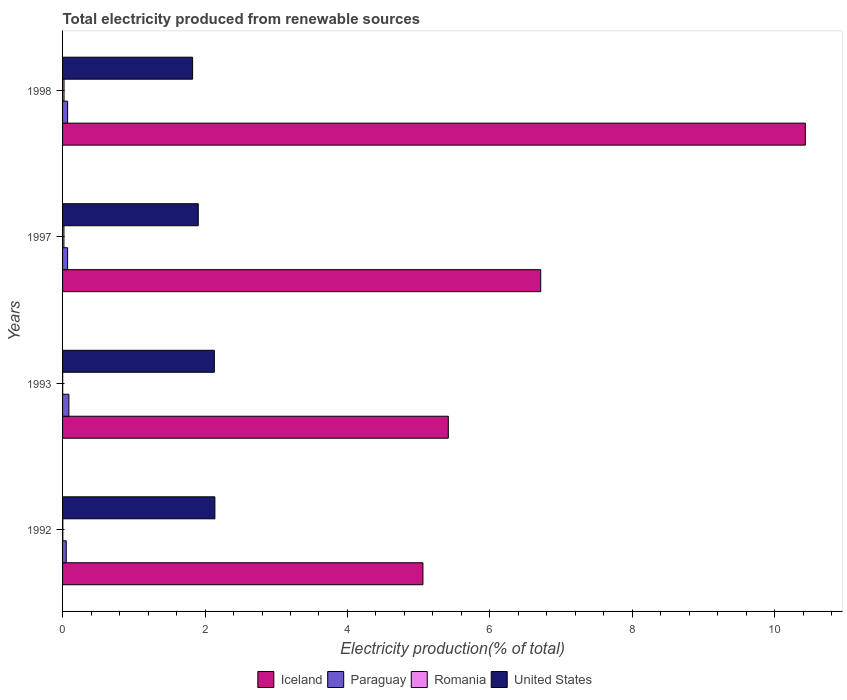How many groups of bars are there?
Offer a terse response. 4. Are the number of bars per tick equal to the number of legend labels?
Provide a succinct answer. Yes. Are the number of bars on each tick of the Y-axis equal?
Provide a short and direct response. Yes. How many bars are there on the 3rd tick from the top?
Your response must be concise. 4. How many bars are there on the 2nd tick from the bottom?
Your response must be concise. 4. What is the total electricity produced in Paraguay in 1993?
Provide a short and direct response. 0.09. Across all years, what is the maximum total electricity produced in United States?
Offer a terse response. 2.14. Across all years, what is the minimum total electricity produced in Paraguay?
Your answer should be very brief. 0.05. In which year was the total electricity produced in Paraguay minimum?
Ensure brevity in your answer.  1992. What is the total total electricity produced in Paraguay in the graph?
Offer a very short reply. 0.28. What is the difference between the total electricity produced in Paraguay in 1993 and that in 1998?
Provide a succinct answer. 0.02. What is the difference between the total electricity produced in Romania in 1993 and the total electricity produced in Iceland in 1998?
Keep it short and to the point. -10.43. What is the average total electricity produced in Paraguay per year?
Provide a succinct answer. 0.07. In the year 1992, what is the difference between the total electricity produced in Romania and total electricity produced in Paraguay?
Keep it short and to the point. -0.05. In how many years, is the total electricity produced in Paraguay greater than 3.2 %?
Ensure brevity in your answer.  0. What is the ratio of the total electricity produced in Paraguay in 1993 to that in 1997?
Offer a very short reply. 1.26. Is the total electricity produced in Romania in 1993 less than that in 1997?
Your answer should be compact. Yes. What is the difference between the highest and the second highest total electricity produced in Romania?
Give a very brief answer. 0. What is the difference between the highest and the lowest total electricity produced in Iceland?
Keep it short and to the point. 5.37. In how many years, is the total electricity produced in Romania greater than the average total electricity produced in Romania taken over all years?
Your answer should be very brief. 2. Is the sum of the total electricity produced in United States in 1992 and 1997 greater than the maximum total electricity produced in Paraguay across all years?
Provide a succinct answer. Yes. Is it the case that in every year, the sum of the total electricity produced in Paraguay and total electricity produced in United States is greater than the sum of total electricity produced in Iceland and total electricity produced in Romania?
Your response must be concise. Yes. What does the 1st bar from the top in 1998 represents?
Your answer should be compact. United States. What does the 3rd bar from the bottom in 1997 represents?
Give a very brief answer. Romania. Is it the case that in every year, the sum of the total electricity produced in Iceland and total electricity produced in United States is greater than the total electricity produced in Paraguay?
Your answer should be compact. Yes. How many years are there in the graph?
Make the answer very short. 4. What is the difference between two consecutive major ticks on the X-axis?
Ensure brevity in your answer.  2. Does the graph contain any zero values?
Your response must be concise. No. How many legend labels are there?
Provide a succinct answer. 4. What is the title of the graph?
Offer a terse response. Total electricity produced from renewable sources. What is the label or title of the Y-axis?
Make the answer very short. Years. What is the Electricity production(% of total) of Iceland in 1992?
Provide a succinct answer. 5.06. What is the Electricity production(% of total) of Paraguay in 1992?
Provide a short and direct response. 0.05. What is the Electricity production(% of total) of Romania in 1992?
Ensure brevity in your answer.  0. What is the Electricity production(% of total) of United States in 1992?
Your response must be concise. 2.14. What is the Electricity production(% of total) of Iceland in 1993?
Your answer should be compact. 5.42. What is the Electricity production(% of total) of Paraguay in 1993?
Make the answer very short. 0.09. What is the Electricity production(% of total) in Romania in 1993?
Your answer should be compact. 0. What is the Electricity production(% of total) of United States in 1993?
Your answer should be compact. 2.13. What is the Electricity production(% of total) of Iceland in 1997?
Your answer should be compact. 6.71. What is the Electricity production(% of total) in Paraguay in 1997?
Offer a terse response. 0.07. What is the Electricity production(% of total) of Romania in 1997?
Provide a succinct answer. 0.02. What is the Electricity production(% of total) of United States in 1997?
Provide a succinct answer. 1.9. What is the Electricity production(% of total) in Iceland in 1998?
Offer a terse response. 10.43. What is the Electricity production(% of total) in Paraguay in 1998?
Your answer should be compact. 0.07. What is the Electricity production(% of total) of Romania in 1998?
Make the answer very short. 0.02. What is the Electricity production(% of total) in United States in 1998?
Your response must be concise. 1.83. Across all years, what is the maximum Electricity production(% of total) in Iceland?
Make the answer very short. 10.43. Across all years, what is the maximum Electricity production(% of total) in Paraguay?
Keep it short and to the point. 0.09. Across all years, what is the maximum Electricity production(% of total) in Romania?
Give a very brief answer. 0.02. Across all years, what is the maximum Electricity production(% of total) in United States?
Offer a very short reply. 2.14. Across all years, what is the minimum Electricity production(% of total) in Iceland?
Give a very brief answer. 5.06. Across all years, what is the minimum Electricity production(% of total) of Paraguay?
Provide a succinct answer. 0.05. Across all years, what is the minimum Electricity production(% of total) in Romania?
Provide a succinct answer. 0. Across all years, what is the minimum Electricity production(% of total) in United States?
Your answer should be compact. 1.83. What is the total Electricity production(% of total) of Iceland in the graph?
Provide a succinct answer. 27.62. What is the total Electricity production(% of total) in Paraguay in the graph?
Your response must be concise. 0.28. What is the total Electricity production(% of total) in Romania in the graph?
Provide a short and direct response. 0.05. What is the total Electricity production(% of total) of United States in the graph?
Give a very brief answer. 8. What is the difference between the Electricity production(% of total) in Iceland in 1992 and that in 1993?
Give a very brief answer. -0.36. What is the difference between the Electricity production(% of total) in Paraguay in 1992 and that in 1993?
Provide a short and direct response. -0.04. What is the difference between the Electricity production(% of total) in Romania in 1992 and that in 1993?
Keep it short and to the point. 0. What is the difference between the Electricity production(% of total) in United States in 1992 and that in 1993?
Give a very brief answer. 0.01. What is the difference between the Electricity production(% of total) in Iceland in 1992 and that in 1997?
Offer a very short reply. -1.65. What is the difference between the Electricity production(% of total) in Paraguay in 1992 and that in 1997?
Provide a short and direct response. -0.02. What is the difference between the Electricity production(% of total) in Romania in 1992 and that in 1997?
Keep it short and to the point. -0.02. What is the difference between the Electricity production(% of total) of United States in 1992 and that in 1997?
Your answer should be very brief. 0.23. What is the difference between the Electricity production(% of total) of Iceland in 1992 and that in 1998?
Your response must be concise. -5.37. What is the difference between the Electricity production(% of total) of Paraguay in 1992 and that in 1998?
Provide a succinct answer. -0.02. What is the difference between the Electricity production(% of total) in Romania in 1992 and that in 1998?
Give a very brief answer. -0.02. What is the difference between the Electricity production(% of total) of United States in 1992 and that in 1998?
Offer a terse response. 0.31. What is the difference between the Electricity production(% of total) in Iceland in 1993 and that in 1997?
Your answer should be compact. -1.3. What is the difference between the Electricity production(% of total) of Paraguay in 1993 and that in 1997?
Provide a short and direct response. 0.02. What is the difference between the Electricity production(% of total) of Romania in 1993 and that in 1997?
Offer a very short reply. -0.02. What is the difference between the Electricity production(% of total) in United States in 1993 and that in 1997?
Offer a very short reply. 0.23. What is the difference between the Electricity production(% of total) of Iceland in 1993 and that in 1998?
Your answer should be very brief. -5.01. What is the difference between the Electricity production(% of total) of Paraguay in 1993 and that in 1998?
Ensure brevity in your answer.  0.02. What is the difference between the Electricity production(% of total) in Romania in 1993 and that in 1998?
Your response must be concise. -0.02. What is the difference between the Electricity production(% of total) of United States in 1993 and that in 1998?
Offer a very short reply. 0.31. What is the difference between the Electricity production(% of total) of Iceland in 1997 and that in 1998?
Ensure brevity in your answer.  -3.72. What is the difference between the Electricity production(% of total) of Romania in 1997 and that in 1998?
Give a very brief answer. -0. What is the difference between the Electricity production(% of total) in United States in 1997 and that in 1998?
Keep it short and to the point. 0.08. What is the difference between the Electricity production(% of total) in Iceland in 1992 and the Electricity production(% of total) in Paraguay in 1993?
Offer a terse response. 4.97. What is the difference between the Electricity production(% of total) of Iceland in 1992 and the Electricity production(% of total) of Romania in 1993?
Offer a terse response. 5.06. What is the difference between the Electricity production(% of total) of Iceland in 1992 and the Electricity production(% of total) of United States in 1993?
Offer a terse response. 2.93. What is the difference between the Electricity production(% of total) of Paraguay in 1992 and the Electricity production(% of total) of Romania in 1993?
Offer a terse response. 0.05. What is the difference between the Electricity production(% of total) in Paraguay in 1992 and the Electricity production(% of total) in United States in 1993?
Provide a short and direct response. -2.08. What is the difference between the Electricity production(% of total) of Romania in 1992 and the Electricity production(% of total) of United States in 1993?
Give a very brief answer. -2.13. What is the difference between the Electricity production(% of total) of Iceland in 1992 and the Electricity production(% of total) of Paraguay in 1997?
Give a very brief answer. 4.99. What is the difference between the Electricity production(% of total) in Iceland in 1992 and the Electricity production(% of total) in Romania in 1997?
Provide a succinct answer. 5.04. What is the difference between the Electricity production(% of total) of Iceland in 1992 and the Electricity production(% of total) of United States in 1997?
Your answer should be compact. 3.15. What is the difference between the Electricity production(% of total) of Paraguay in 1992 and the Electricity production(% of total) of Romania in 1997?
Ensure brevity in your answer.  0.03. What is the difference between the Electricity production(% of total) of Paraguay in 1992 and the Electricity production(% of total) of United States in 1997?
Ensure brevity in your answer.  -1.85. What is the difference between the Electricity production(% of total) in Romania in 1992 and the Electricity production(% of total) in United States in 1997?
Offer a terse response. -1.9. What is the difference between the Electricity production(% of total) of Iceland in 1992 and the Electricity production(% of total) of Paraguay in 1998?
Make the answer very short. 4.99. What is the difference between the Electricity production(% of total) in Iceland in 1992 and the Electricity production(% of total) in Romania in 1998?
Keep it short and to the point. 5.04. What is the difference between the Electricity production(% of total) of Iceland in 1992 and the Electricity production(% of total) of United States in 1998?
Ensure brevity in your answer.  3.23. What is the difference between the Electricity production(% of total) of Paraguay in 1992 and the Electricity production(% of total) of Romania in 1998?
Your answer should be compact. 0.03. What is the difference between the Electricity production(% of total) of Paraguay in 1992 and the Electricity production(% of total) of United States in 1998?
Your answer should be very brief. -1.77. What is the difference between the Electricity production(% of total) in Romania in 1992 and the Electricity production(% of total) in United States in 1998?
Ensure brevity in your answer.  -1.82. What is the difference between the Electricity production(% of total) in Iceland in 1993 and the Electricity production(% of total) in Paraguay in 1997?
Give a very brief answer. 5.34. What is the difference between the Electricity production(% of total) of Iceland in 1993 and the Electricity production(% of total) of Romania in 1997?
Offer a very short reply. 5.4. What is the difference between the Electricity production(% of total) of Iceland in 1993 and the Electricity production(% of total) of United States in 1997?
Make the answer very short. 3.51. What is the difference between the Electricity production(% of total) of Paraguay in 1993 and the Electricity production(% of total) of Romania in 1997?
Provide a short and direct response. 0.07. What is the difference between the Electricity production(% of total) of Paraguay in 1993 and the Electricity production(% of total) of United States in 1997?
Offer a very short reply. -1.82. What is the difference between the Electricity production(% of total) of Romania in 1993 and the Electricity production(% of total) of United States in 1997?
Your answer should be compact. -1.9. What is the difference between the Electricity production(% of total) of Iceland in 1993 and the Electricity production(% of total) of Paraguay in 1998?
Your answer should be compact. 5.34. What is the difference between the Electricity production(% of total) in Iceland in 1993 and the Electricity production(% of total) in Romania in 1998?
Give a very brief answer. 5.4. What is the difference between the Electricity production(% of total) of Iceland in 1993 and the Electricity production(% of total) of United States in 1998?
Provide a succinct answer. 3.59. What is the difference between the Electricity production(% of total) in Paraguay in 1993 and the Electricity production(% of total) in Romania in 1998?
Provide a succinct answer. 0.07. What is the difference between the Electricity production(% of total) of Paraguay in 1993 and the Electricity production(% of total) of United States in 1998?
Provide a short and direct response. -1.74. What is the difference between the Electricity production(% of total) in Romania in 1993 and the Electricity production(% of total) in United States in 1998?
Provide a succinct answer. -1.82. What is the difference between the Electricity production(% of total) of Iceland in 1997 and the Electricity production(% of total) of Paraguay in 1998?
Offer a very short reply. 6.64. What is the difference between the Electricity production(% of total) of Iceland in 1997 and the Electricity production(% of total) of Romania in 1998?
Give a very brief answer. 6.69. What is the difference between the Electricity production(% of total) in Iceland in 1997 and the Electricity production(% of total) in United States in 1998?
Keep it short and to the point. 4.89. What is the difference between the Electricity production(% of total) in Paraguay in 1997 and the Electricity production(% of total) in Romania in 1998?
Provide a succinct answer. 0.05. What is the difference between the Electricity production(% of total) in Paraguay in 1997 and the Electricity production(% of total) in United States in 1998?
Your answer should be compact. -1.76. What is the difference between the Electricity production(% of total) in Romania in 1997 and the Electricity production(% of total) in United States in 1998?
Provide a short and direct response. -1.81. What is the average Electricity production(% of total) in Iceland per year?
Ensure brevity in your answer.  6.9. What is the average Electricity production(% of total) of Paraguay per year?
Ensure brevity in your answer.  0.07. What is the average Electricity production(% of total) of Romania per year?
Offer a terse response. 0.01. What is the average Electricity production(% of total) of United States per year?
Your answer should be compact. 2. In the year 1992, what is the difference between the Electricity production(% of total) in Iceland and Electricity production(% of total) in Paraguay?
Provide a short and direct response. 5.01. In the year 1992, what is the difference between the Electricity production(% of total) of Iceland and Electricity production(% of total) of Romania?
Your answer should be compact. 5.06. In the year 1992, what is the difference between the Electricity production(% of total) of Iceland and Electricity production(% of total) of United States?
Ensure brevity in your answer.  2.92. In the year 1992, what is the difference between the Electricity production(% of total) in Paraguay and Electricity production(% of total) in Romania?
Give a very brief answer. 0.05. In the year 1992, what is the difference between the Electricity production(% of total) in Paraguay and Electricity production(% of total) in United States?
Offer a terse response. -2.09. In the year 1992, what is the difference between the Electricity production(% of total) of Romania and Electricity production(% of total) of United States?
Provide a short and direct response. -2.13. In the year 1993, what is the difference between the Electricity production(% of total) in Iceland and Electricity production(% of total) in Paraguay?
Offer a very short reply. 5.33. In the year 1993, what is the difference between the Electricity production(% of total) of Iceland and Electricity production(% of total) of Romania?
Your answer should be very brief. 5.41. In the year 1993, what is the difference between the Electricity production(% of total) in Iceland and Electricity production(% of total) in United States?
Offer a terse response. 3.28. In the year 1993, what is the difference between the Electricity production(% of total) in Paraguay and Electricity production(% of total) in Romania?
Provide a succinct answer. 0.09. In the year 1993, what is the difference between the Electricity production(% of total) of Paraguay and Electricity production(% of total) of United States?
Make the answer very short. -2.04. In the year 1993, what is the difference between the Electricity production(% of total) in Romania and Electricity production(% of total) in United States?
Provide a succinct answer. -2.13. In the year 1997, what is the difference between the Electricity production(% of total) in Iceland and Electricity production(% of total) in Paraguay?
Keep it short and to the point. 6.64. In the year 1997, what is the difference between the Electricity production(% of total) in Iceland and Electricity production(% of total) in Romania?
Make the answer very short. 6.69. In the year 1997, what is the difference between the Electricity production(% of total) in Iceland and Electricity production(% of total) in United States?
Your answer should be compact. 4.81. In the year 1997, what is the difference between the Electricity production(% of total) of Paraguay and Electricity production(% of total) of Romania?
Provide a short and direct response. 0.05. In the year 1997, what is the difference between the Electricity production(% of total) in Paraguay and Electricity production(% of total) in United States?
Keep it short and to the point. -1.83. In the year 1997, what is the difference between the Electricity production(% of total) of Romania and Electricity production(% of total) of United States?
Your answer should be very brief. -1.89. In the year 1998, what is the difference between the Electricity production(% of total) in Iceland and Electricity production(% of total) in Paraguay?
Provide a short and direct response. 10.36. In the year 1998, what is the difference between the Electricity production(% of total) of Iceland and Electricity production(% of total) of Romania?
Offer a terse response. 10.41. In the year 1998, what is the difference between the Electricity production(% of total) of Iceland and Electricity production(% of total) of United States?
Provide a short and direct response. 8.6. In the year 1998, what is the difference between the Electricity production(% of total) in Paraguay and Electricity production(% of total) in Romania?
Your response must be concise. 0.05. In the year 1998, what is the difference between the Electricity production(% of total) in Paraguay and Electricity production(% of total) in United States?
Provide a succinct answer. -1.76. In the year 1998, what is the difference between the Electricity production(% of total) in Romania and Electricity production(% of total) in United States?
Make the answer very short. -1.81. What is the ratio of the Electricity production(% of total) of Iceland in 1992 to that in 1993?
Give a very brief answer. 0.93. What is the ratio of the Electricity production(% of total) in Paraguay in 1992 to that in 1993?
Offer a terse response. 0.58. What is the ratio of the Electricity production(% of total) in Romania in 1992 to that in 1993?
Keep it short and to the point. 2.05. What is the ratio of the Electricity production(% of total) of United States in 1992 to that in 1993?
Offer a terse response. 1. What is the ratio of the Electricity production(% of total) in Iceland in 1992 to that in 1997?
Your answer should be very brief. 0.75. What is the ratio of the Electricity production(% of total) of Paraguay in 1992 to that in 1997?
Offer a terse response. 0.73. What is the ratio of the Electricity production(% of total) of Romania in 1992 to that in 1997?
Your response must be concise. 0.19. What is the ratio of the Electricity production(% of total) in United States in 1992 to that in 1997?
Keep it short and to the point. 1.12. What is the ratio of the Electricity production(% of total) in Iceland in 1992 to that in 1998?
Your response must be concise. 0.49. What is the ratio of the Electricity production(% of total) of Paraguay in 1992 to that in 1998?
Give a very brief answer. 0.73. What is the ratio of the Electricity production(% of total) of Romania in 1992 to that in 1998?
Give a very brief answer. 0.18. What is the ratio of the Electricity production(% of total) of United States in 1992 to that in 1998?
Your response must be concise. 1.17. What is the ratio of the Electricity production(% of total) in Iceland in 1993 to that in 1997?
Keep it short and to the point. 0.81. What is the ratio of the Electricity production(% of total) of Paraguay in 1993 to that in 1997?
Your answer should be compact. 1.26. What is the ratio of the Electricity production(% of total) of Romania in 1993 to that in 1997?
Offer a very short reply. 0.09. What is the ratio of the Electricity production(% of total) of United States in 1993 to that in 1997?
Give a very brief answer. 1.12. What is the ratio of the Electricity production(% of total) in Iceland in 1993 to that in 1998?
Your response must be concise. 0.52. What is the ratio of the Electricity production(% of total) in Paraguay in 1993 to that in 1998?
Ensure brevity in your answer.  1.26. What is the ratio of the Electricity production(% of total) of Romania in 1993 to that in 1998?
Your answer should be very brief. 0.09. What is the ratio of the Electricity production(% of total) in United States in 1993 to that in 1998?
Offer a very short reply. 1.17. What is the ratio of the Electricity production(% of total) of Iceland in 1997 to that in 1998?
Offer a terse response. 0.64. What is the ratio of the Electricity production(% of total) of Romania in 1997 to that in 1998?
Your response must be concise. 0.94. What is the ratio of the Electricity production(% of total) of United States in 1997 to that in 1998?
Offer a terse response. 1.04. What is the difference between the highest and the second highest Electricity production(% of total) in Iceland?
Provide a short and direct response. 3.72. What is the difference between the highest and the second highest Electricity production(% of total) of Paraguay?
Offer a very short reply. 0.02. What is the difference between the highest and the second highest Electricity production(% of total) of Romania?
Your answer should be compact. 0. What is the difference between the highest and the second highest Electricity production(% of total) in United States?
Your answer should be compact. 0.01. What is the difference between the highest and the lowest Electricity production(% of total) in Iceland?
Your answer should be very brief. 5.37. What is the difference between the highest and the lowest Electricity production(% of total) of Paraguay?
Make the answer very short. 0.04. What is the difference between the highest and the lowest Electricity production(% of total) of Romania?
Provide a short and direct response. 0.02. What is the difference between the highest and the lowest Electricity production(% of total) of United States?
Keep it short and to the point. 0.31. 